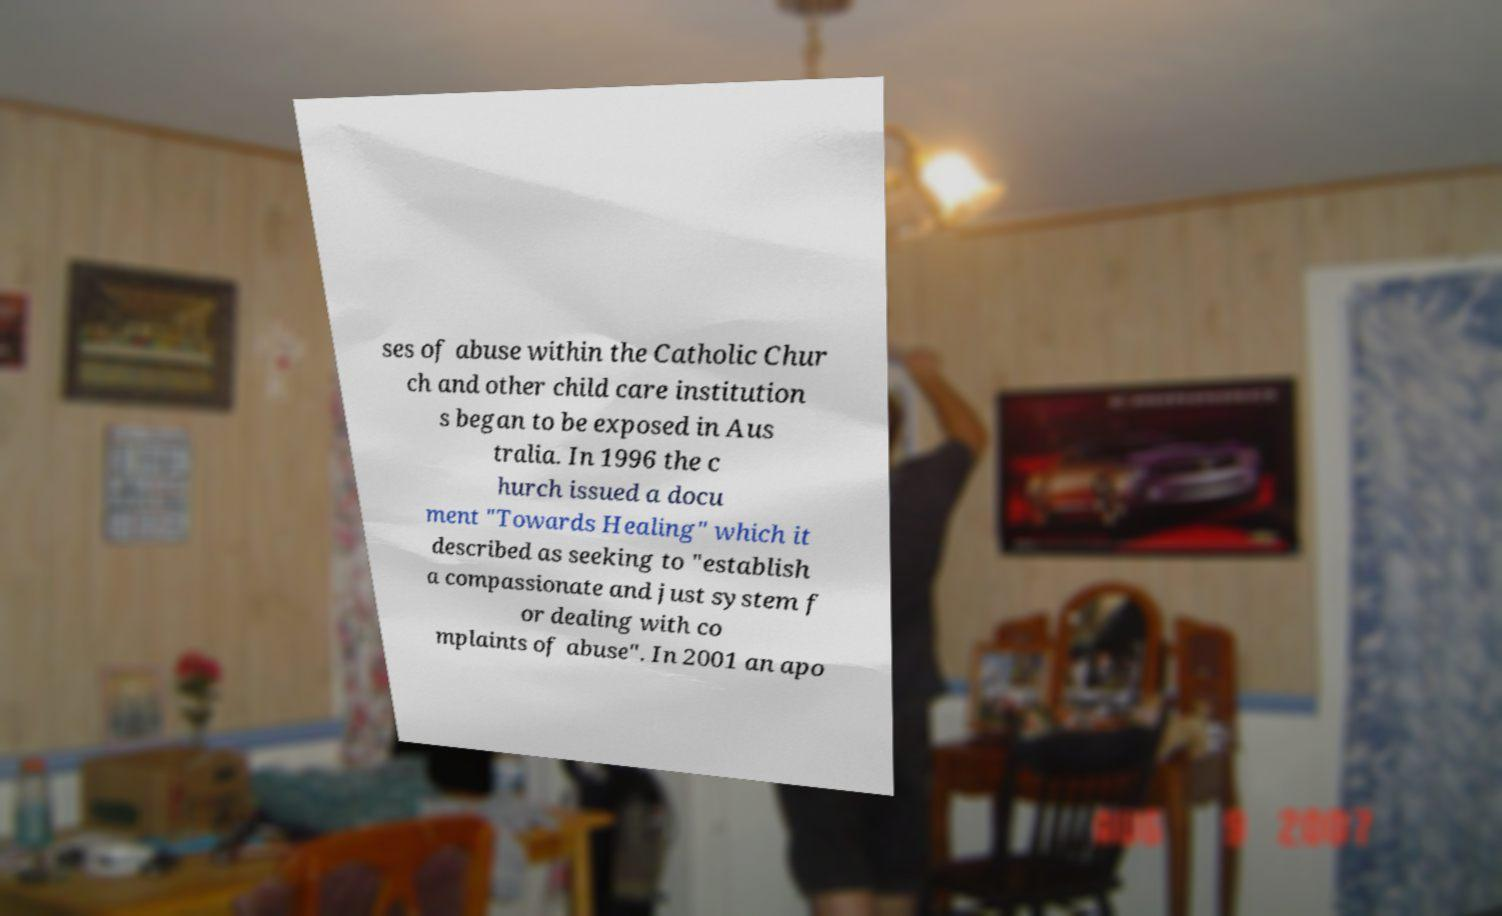Could you assist in decoding the text presented in this image and type it out clearly? ses of abuse within the Catholic Chur ch and other child care institution s began to be exposed in Aus tralia. In 1996 the c hurch issued a docu ment "Towards Healing" which it described as seeking to "establish a compassionate and just system f or dealing with co mplaints of abuse". In 2001 an apo 